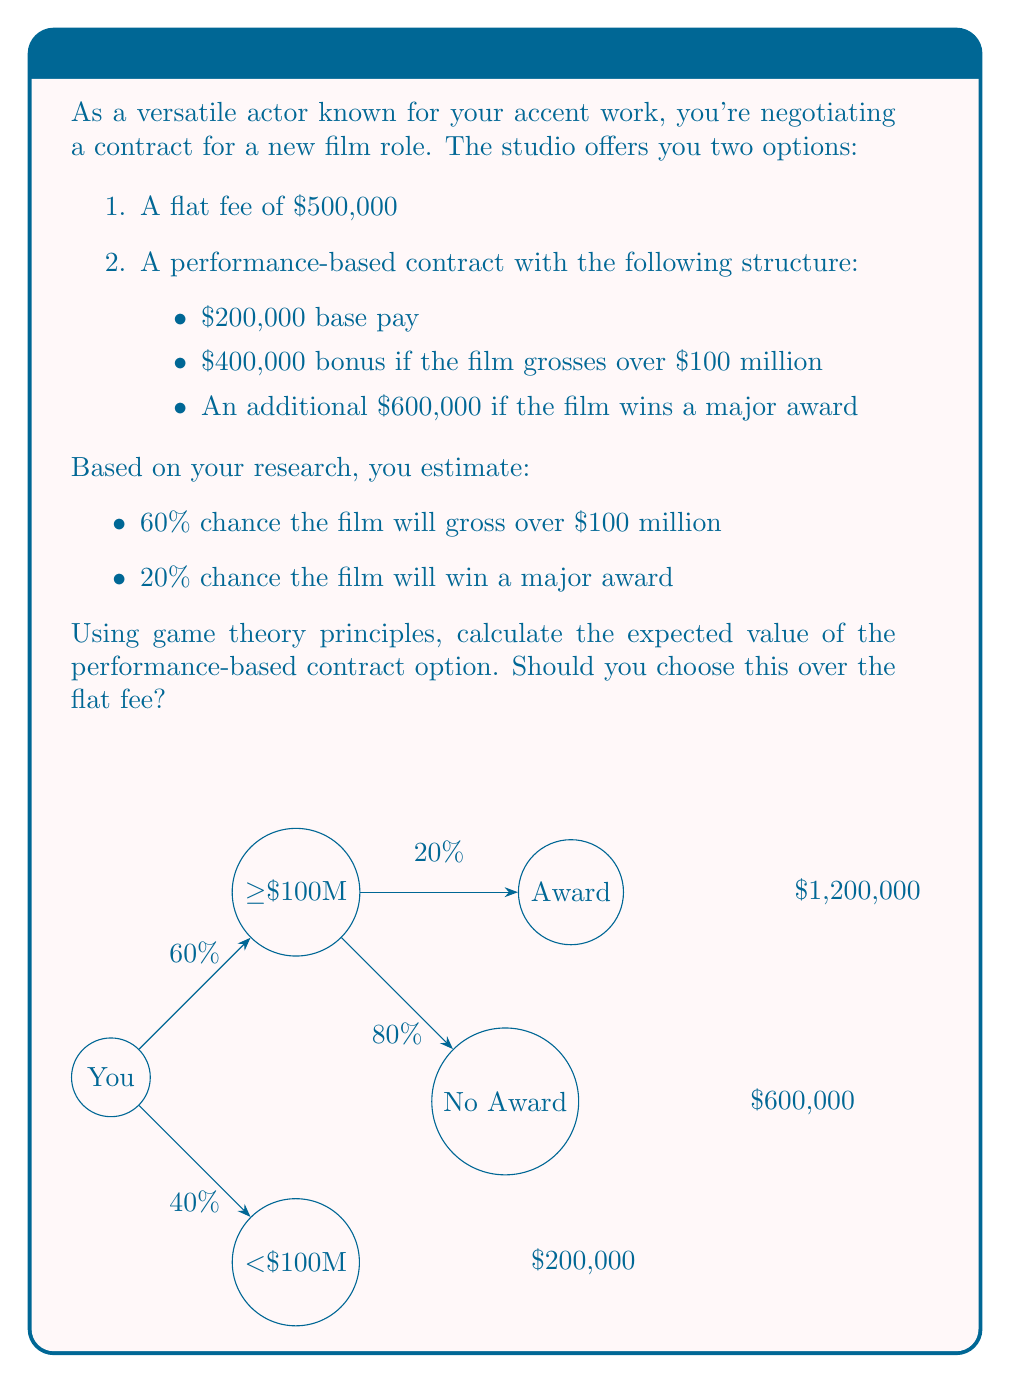Give your solution to this math problem. Let's break this down step-by-step using the principles of expected value from game theory:

1) First, let's identify all possible outcomes and their probabilities:

   a) Film grosses over $100M and wins award: 
      Probability = 0.60 * 0.20 = 0.12
   b) Film grosses over $100M but doesn't win award: 
      Probability = 0.60 * 0.80 = 0.48
   c) Film grosses under $100M: 
      Probability = 0.40

2) Now, let's calculate the payoff for each outcome:

   a) $200,000 + $400,000 + $600,000 = $1,200,000
   b) $200,000 + $400,000 = $600,000
   c) $200,000

3) The expected value is the sum of each outcome's probability multiplied by its payoff:

   $$ E = (0.12 * 1,200,000) + (0.48 * 600,000) + (0.40 * 200,000) $$

4) Let's calculate each term:

   $$ E = 144,000 + 288,000 + 80,000 $$

5) Sum up the terms:

   $$ E = 512,000 $$

6) Compare this to the flat fee offer of $500,000:

   The expected value of the performance-based contract ($512,000) is higher than the flat fee ($500,000).
Answer: $512,000; Choose performance-based contract 